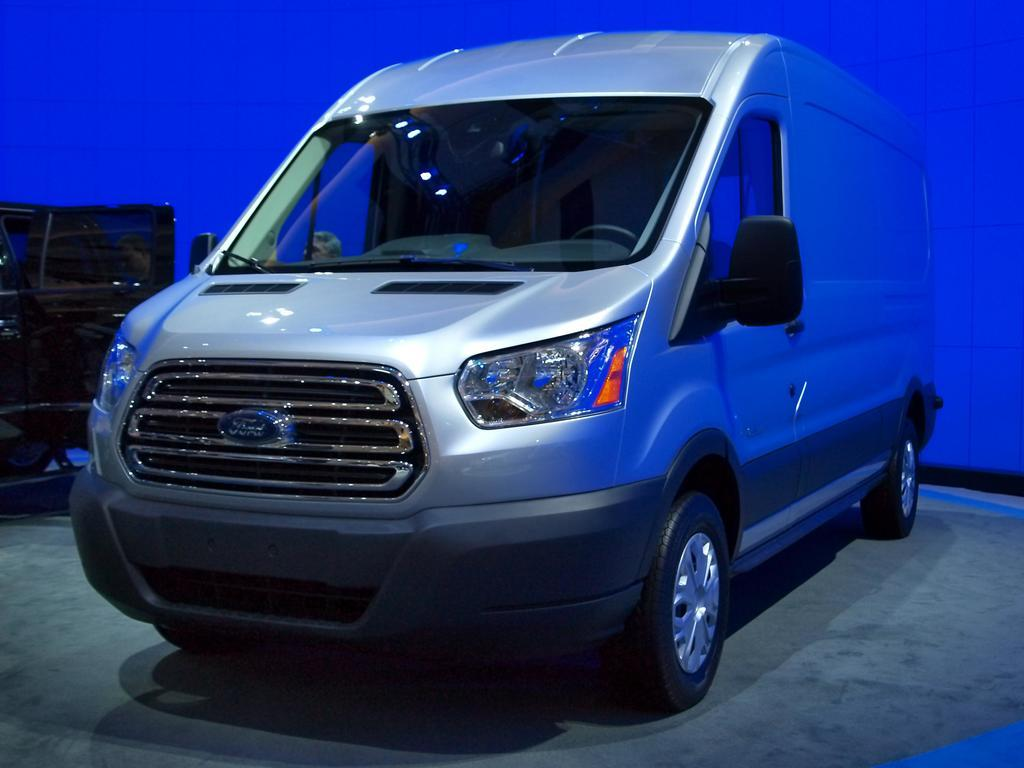How many vehicles are present in the image? There are two vehicles in the image. What else can be seen in the image besides the vehicles? There are two people standing in the image. What is the color of the background in the image? The background color is blue. What type of brass instrument is being played by one of the people in the image? There is no brass instrument or indication of any musical activity in the image. 